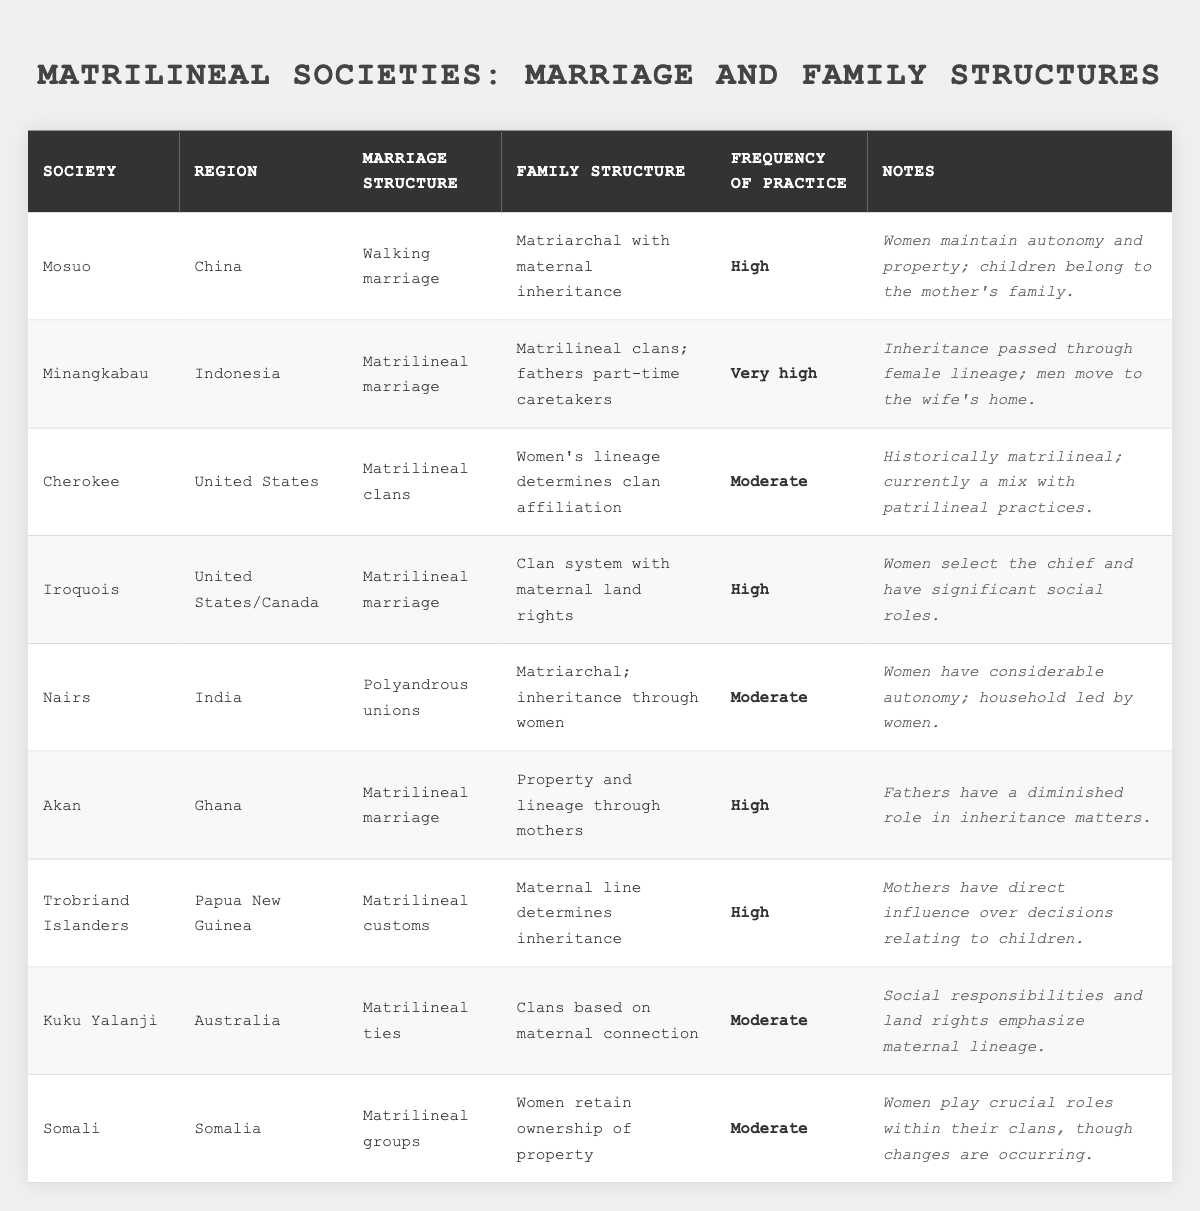What is the marriage structure of the Minangkabau society? The table lists the Minangkabau society under the "Society" column, and indicates their marriage structure in the corresponding column, which is "Matrilineal marriage".
Answer: Matrilineal marriage Which society has the highest frequency of matrilineal practices? By reviewing the "Frequency of Practice" column, it's clear that the Minangkabau society has the description "Very high".
Answer: Minangkabau In which region do the Iroquois people reside? The region related to the Iroquois is mentioned in the "Region" column, which states "United States/Canada".
Answer: United States/Canada How many societies have a moderate frequency of practice? Counting the societies listed as "Moderate" in the "Frequency of Practice" column, we find there are three: Cherokee, Nairs, Kuku Yalanji, and Somali.
Answer: 4 What is the family structure for the Mosuo society? The family structure is specified in the table under Mosuo, which is "Matriarchal with maternal inheritance".
Answer: Matriarchal with maternal inheritance Is it true that women in the Akan society have a diminished role in inheritance matters? The notes column details that fathers have a diminished role in inheritance matters within the Akan society, thus confirming that the statement is true.
Answer: True Do women in the Trobriand Islanders have any influence over decisions relating to children? The notes for the Trobriand Islanders state that mothers have direct influence over decisions regarding children, indicating that this statement is indeed correct.
Answer: Yes What is the marriage structure and family structure of the Somali society? Referring to the table, the Somali society has a "Matrilineal groups" marriage structure and a family structure where "Women retain ownership of property".
Answer: Matrilineal groups; Women retain ownership of property Which societies practice matrilineal customs and have a high frequency of practice? The societies that practice matrilineal customs with a high frequency are Mosuo, Iroquois, Akan, and Trobriand Islanders.
Answer: Mosuo, Iroquois, Akan, Trobriand Islanders If you were to rank the societies based on the frequency of practice, which society would be second? The ranking based on the frequency reveals that after Minangkabau (very high), the Iroquois and Mosuo both have 'High' status. Since they are tied, the second ranking can include both.
Answer: Iroquois and Mosuo 